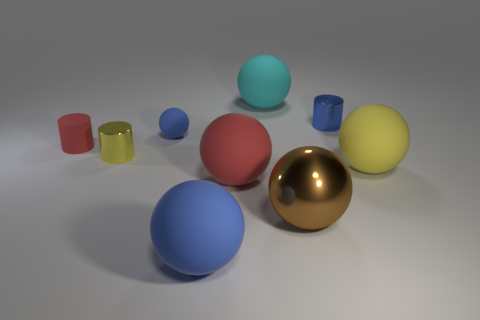What materials are used to simulate the appearances of the objects in this image? The objects in the image including the spheres and cylinders have been digitally rendered to simulate various materials. The shiny sphere looks like polished metal, possibly gold, while the cylinders and spheres have matte textures resembling plastic or ceramics. Each object’s texture and lighting contribute to the illusion of different materials. 